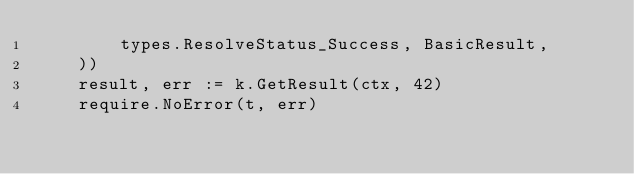<code> <loc_0><loc_0><loc_500><loc_500><_Go_>		types.ResolveStatus_Success, BasicResult,
	))
	result, err := k.GetResult(ctx, 42)
	require.NoError(t, err)</code> 